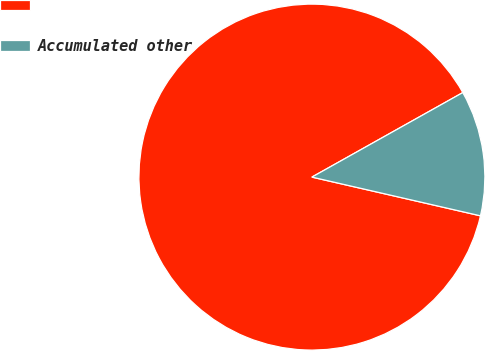Convert chart. <chart><loc_0><loc_0><loc_500><loc_500><pie_chart><ecel><fcel>Accumulated other<nl><fcel>88.28%<fcel>11.72%<nl></chart> 